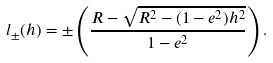<formula> <loc_0><loc_0><loc_500><loc_500>l _ { \pm } ( h ) = \pm \left ( \frac { R - \sqrt { R ^ { 2 } - ( 1 - e ^ { 2 } ) h ^ { 2 } } } { 1 - e ^ { 2 } } \right ) .</formula> 